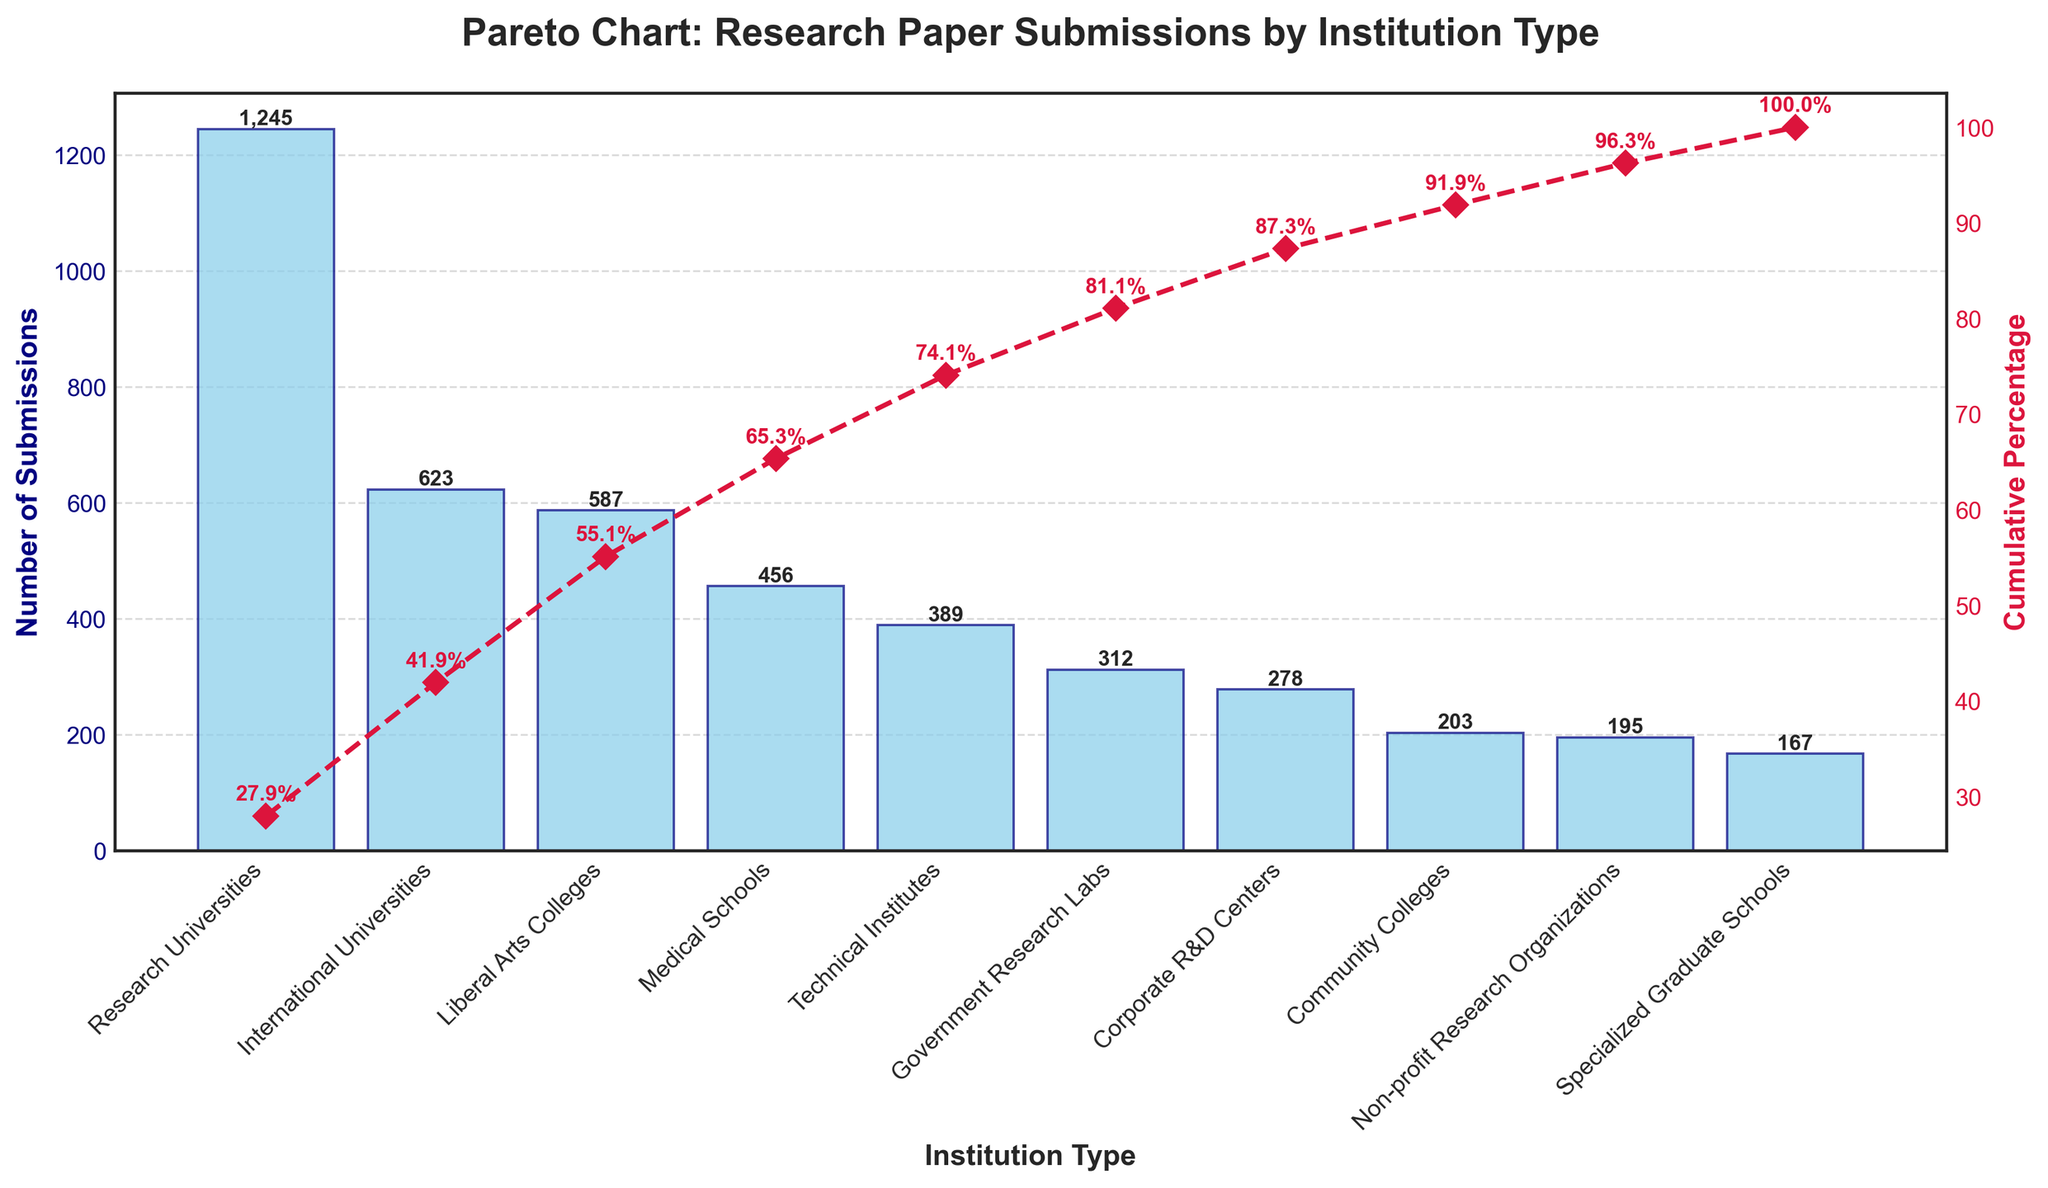What is the title of the figure? The title of the figure is visible at the top of the plot. It states "Pareto Chart: Research Paper Submissions by Institution Type" in bold, large font.
Answer: Pareto Chart: Research Paper Submissions by Institution Type Which institution type has the highest number of research paper submissions? The bar representing the "Research Universities" is the tallest and has the highest value label among all types of institutions, indicating it has the highest number of submissions.
Answer: Research Universities What percentage of the total submissions do Research Universities and International Universities contribute together? Adding the number of submissions for Research Universities (1245) and International Universities (623) and then calculating their percentage of the total number of submissions, we get (1245 + 623) / (1245 + 587 + 203 + 456 + 389 + 312 + 278 + 195 + 623 + 167) * 100 ≈ 49.8%.
Answer: 49.8% Which institution type ranks third in the number of research paper submissions? From the descending order of the bars, we see the third tallest bar represents "International Universities" with 623 submissions.
Answer: International Universities What is the cumulative percentage for the top four institution types in the chart? The cumulative percentages are marked with red dots and labels. The sum of the percentages for Research Universities (28.0%), International Universities (42.0%), Liberal Arts Colleges (55.0%), and Medical Schools (65.3%) is 65.3%.
Answer: 65.3% How many types of institutions have fewer than 250 submissions each? By looking at the heights of the bars and their respective value labels, we count the bars with numbers below 250, which are "Community Colleges," "Non-profit Research Organizations," and "Specialized Graduate Schools," totaling 3 institution types.
Answer: 3 Is there a clear distinction in submissions between Research Universities and Liberal Arts Colleges? The value for Research Universities (1245) is significantly higher than that for Liberal Arts Colleges (587), showing a clear distinction in the number of submissions.
Answer: Yes Which type of institution provides the smallest number of research paper submissions? The shortest bar represents "Specialized Graduate Schools" with 167 submissions, making it the institution type with the fewest submissions.
Answer: Specialized Graduate Schools At what cumulative percentage do Corporate R&D Centers appear? The cumulative percentage for Corporate R&D Centers is marked on the red line, which is 87.4% according to the labels.
Answer: 87.4% 